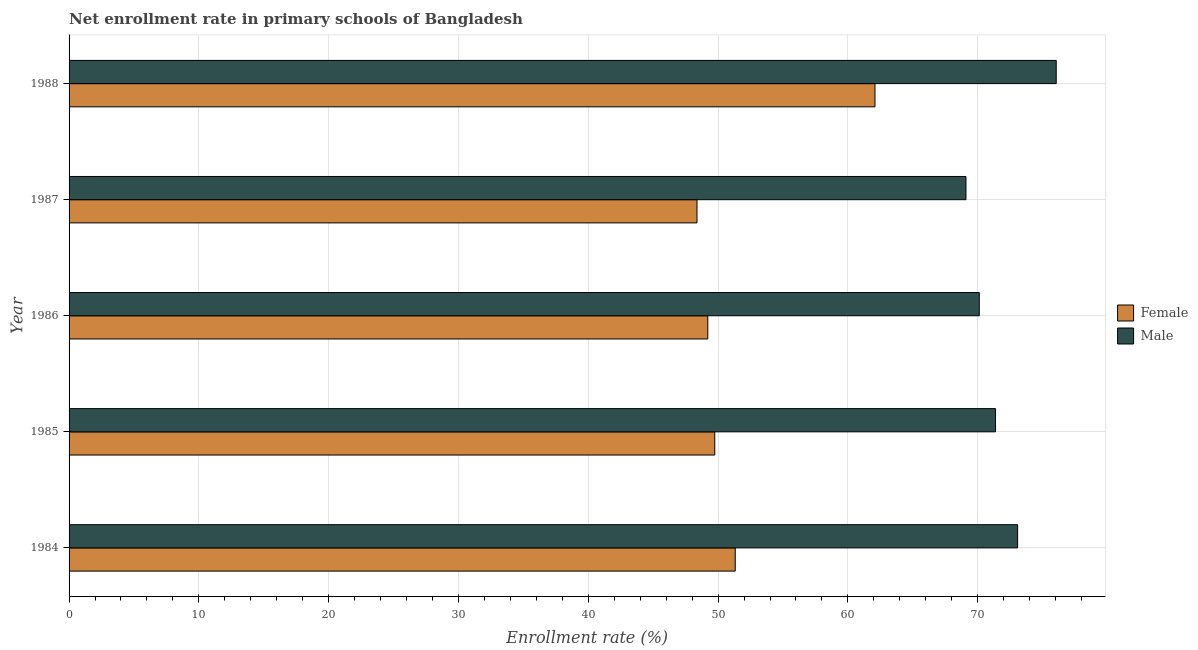How many groups of bars are there?
Ensure brevity in your answer.  5. Are the number of bars per tick equal to the number of legend labels?
Make the answer very short. Yes. Are the number of bars on each tick of the Y-axis equal?
Provide a succinct answer. Yes. How many bars are there on the 4th tick from the top?
Offer a terse response. 2. In how many cases, is the number of bars for a given year not equal to the number of legend labels?
Provide a succinct answer. 0. What is the enrollment rate of female students in 1985?
Keep it short and to the point. 49.74. Across all years, what is the maximum enrollment rate of male students?
Your answer should be very brief. 76.05. Across all years, what is the minimum enrollment rate of female students?
Your answer should be very brief. 48.38. In which year was the enrollment rate of male students maximum?
Offer a terse response. 1988. What is the total enrollment rate of male students in the graph?
Keep it short and to the point. 359.72. What is the difference between the enrollment rate of male students in 1987 and that in 1988?
Give a very brief answer. -6.95. What is the difference between the enrollment rate of male students in 1986 and the enrollment rate of female students in 1987?
Your answer should be compact. 21.75. What is the average enrollment rate of female students per year?
Ensure brevity in your answer.  52.15. In the year 1986, what is the difference between the enrollment rate of female students and enrollment rate of male students?
Your answer should be compact. -20.91. In how many years, is the enrollment rate of female students greater than 18 %?
Make the answer very short. 5. What is the ratio of the enrollment rate of male students in 1985 to that in 1987?
Provide a succinct answer. 1.03. Is the enrollment rate of male students in 1984 less than that in 1986?
Your answer should be very brief. No. What is the difference between the highest and the second highest enrollment rate of male students?
Offer a very short reply. 2.97. What is the difference between the highest and the lowest enrollment rate of female students?
Your answer should be very brief. 13.71. In how many years, is the enrollment rate of male students greater than the average enrollment rate of male students taken over all years?
Provide a short and direct response. 2. Is the sum of the enrollment rate of male students in 1985 and 1987 greater than the maximum enrollment rate of female students across all years?
Your response must be concise. Yes. Are all the bars in the graph horizontal?
Provide a short and direct response. Yes. What is the difference between two consecutive major ticks on the X-axis?
Your answer should be very brief. 10. Are the values on the major ticks of X-axis written in scientific E-notation?
Give a very brief answer. No. How many legend labels are there?
Provide a succinct answer. 2. How are the legend labels stacked?
Make the answer very short. Vertical. What is the title of the graph?
Your answer should be compact. Net enrollment rate in primary schools of Bangladesh. What is the label or title of the X-axis?
Keep it short and to the point. Enrollment rate (%). What is the label or title of the Y-axis?
Keep it short and to the point. Year. What is the Enrollment rate (%) of Female in 1984?
Give a very brief answer. 51.32. What is the Enrollment rate (%) in Male in 1984?
Provide a succinct answer. 73.08. What is the Enrollment rate (%) of Female in 1985?
Ensure brevity in your answer.  49.74. What is the Enrollment rate (%) of Male in 1985?
Provide a succinct answer. 71.38. What is the Enrollment rate (%) in Female in 1986?
Provide a short and direct response. 49.21. What is the Enrollment rate (%) of Male in 1986?
Give a very brief answer. 70.12. What is the Enrollment rate (%) of Female in 1987?
Offer a very short reply. 48.38. What is the Enrollment rate (%) in Male in 1987?
Provide a short and direct response. 69.1. What is the Enrollment rate (%) of Female in 1988?
Give a very brief answer. 62.09. What is the Enrollment rate (%) of Male in 1988?
Offer a terse response. 76.05. Across all years, what is the maximum Enrollment rate (%) of Female?
Provide a short and direct response. 62.09. Across all years, what is the maximum Enrollment rate (%) of Male?
Give a very brief answer. 76.05. Across all years, what is the minimum Enrollment rate (%) of Female?
Provide a short and direct response. 48.38. Across all years, what is the minimum Enrollment rate (%) of Male?
Make the answer very short. 69.1. What is the total Enrollment rate (%) in Female in the graph?
Ensure brevity in your answer.  260.74. What is the total Enrollment rate (%) of Male in the graph?
Offer a terse response. 359.72. What is the difference between the Enrollment rate (%) of Female in 1984 and that in 1985?
Ensure brevity in your answer.  1.58. What is the difference between the Enrollment rate (%) in Male in 1984 and that in 1985?
Provide a short and direct response. 1.7. What is the difference between the Enrollment rate (%) in Female in 1984 and that in 1986?
Keep it short and to the point. 2.11. What is the difference between the Enrollment rate (%) of Male in 1984 and that in 1986?
Provide a short and direct response. 2.95. What is the difference between the Enrollment rate (%) of Female in 1984 and that in 1987?
Provide a succinct answer. 2.95. What is the difference between the Enrollment rate (%) in Male in 1984 and that in 1987?
Ensure brevity in your answer.  3.98. What is the difference between the Enrollment rate (%) in Female in 1984 and that in 1988?
Provide a short and direct response. -10.77. What is the difference between the Enrollment rate (%) of Male in 1984 and that in 1988?
Offer a very short reply. -2.97. What is the difference between the Enrollment rate (%) of Female in 1985 and that in 1986?
Make the answer very short. 0.54. What is the difference between the Enrollment rate (%) of Male in 1985 and that in 1986?
Provide a succinct answer. 1.25. What is the difference between the Enrollment rate (%) in Female in 1985 and that in 1987?
Ensure brevity in your answer.  1.37. What is the difference between the Enrollment rate (%) in Male in 1985 and that in 1987?
Ensure brevity in your answer.  2.28. What is the difference between the Enrollment rate (%) of Female in 1985 and that in 1988?
Offer a terse response. -12.34. What is the difference between the Enrollment rate (%) in Male in 1985 and that in 1988?
Your response must be concise. -4.68. What is the difference between the Enrollment rate (%) in Female in 1986 and that in 1987?
Ensure brevity in your answer.  0.83. What is the difference between the Enrollment rate (%) of Male in 1986 and that in 1987?
Keep it short and to the point. 1.03. What is the difference between the Enrollment rate (%) in Female in 1986 and that in 1988?
Make the answer very short. -12.88. What is the difference between the Enrollment rate (%) of Male in 1986 and that in 1988?
Your response must be concise. -5.93. What is the difference between the Enrollment rate (%) in Female in 1987 and that in 1988?
Give a very brief answer. -13.71. What is the difference between the Enrollment rate (%) of Male in 1987 and that in 1988?
Keep it short and to the point. -6.95. What is the difference between the Enrollment rate (%) of Female in 1984 and the Enrollment rate (%) of Male in 1985?
Offer a terse response. -20.05. What is the difference between the Enrollment rate (%) in Female in 1984 and the Enrollment rate (%) in Male in 1986?
Your response must be concise. -18.8. What is the difference between the Enrollment rate (%) of Female in 1984 and the Enrollment rate (%) of Male in 1987?
Offer a very short reply. -17.78. What is the difference between the Enrollment rate (%) in Female in 1984 and the Enrollment rate (%) in Male in 1988?
Ensure brevity in your answer.  -24.73. What is the difference between the Enrollment rate (%) in Female in 1985 and the Enrollment rate (%) in Male in 1986?
Offer a terse response. -20.38. What is the difference between the Enrollment rate (%) of Female in 1985 and the Enrollment rate (%) of Male in 1987?
Give a very brief answer. -19.35. What is the difference between the Enrollment rate (%) of Female in 1985 and the Enrollment rate (%) of Male in 1988?
Offer a terse response. -26.31. What is the difference between the Enrollment rate (%) in Female in 1986 and the Enrollment rate (%) in Male in 1987?
Give a very brief answer. -19.89. What is the difference between the Enrollment rate (%) of Female in 1986 and the Enrollment rate (%) of Male in 1988?
Provide a short and direct response. -26.84. What is the difference between the Enrollment rate (%) in Female in 1987 and the Enrollment rate (%) in Male in 1988?
Provide a short and direct response. -27.68. What is the average Enrollment rate (%) in Female per year?
Your response must be concise. 52.15. What is the average Enrollment rate (%) in Male per year?
Your answer should be compact. 71.94. In the year 1984, what is the difference between the Enrollment rate (%) of Female and Enrollment rate (%) of Male?
Keep it short and to the point. -21.76. In the year 1985, what is the difference between the Enrollment rate (%) in Female and Enrollment rate (%) in Male?
Give a very brief answer. -21.63. In the year 1986, what is the difference between the Enrollment rate (%) of Female and Enrollment rate (%) of Male?
Provide a short and direct response. -20.91. In the year 1987, what is the difference between the Enrollment rate (%) in Female and Enrollment rate (%) in Male?
Offer a terse response. -20.72. In the year 1988, what is the difference between the Enrollment rate (%) in Female and Enrollment rate (%) in Male?
Ensure brevity in your answer.  -13.96. What is the ratio of the Enrollment rate (%) of Female in 1984 to that in 1985?
Provide a succinct answer. 1.03. What is the ratio of the Enrollment rate (%) of Male in 1984 to that in 1985?
Your answer should be compact. 1.02. What is the ratio of the Enrollment rate (%) in Female in 1984 to that in 1986?
Keep it short and to the point. 1.04. What is the ratio of the Enrollment rate (%) of Male in 1984 to that in 1986?
Offer a terse response. 1.04. What is the ratio of the Enrollment rate (%) of Female in 1984 to that in 1987?
Offer a terse response. 1.06. What is the ratio of the Enrollment rate (%) of Male in 1984 to that in 1987?
Offer a very short reply. 1.06. What is the ratio of the Enrollment rate (%) in Female in 1984 to that in 1988?
Provide a succinct answer. 0.83. What is the ratio of the Enrollment rate (%) in Male in 1984 to that in 1988?
Provide a short and direct response. 0.96. What is the ratio of the Enrollment rate (%) of Female in 1985 to that in 1986?
Keep it short and to the point. 1.01. What is the ratio of the Enrollment rate (%) of Male in 1985 to that in 1986?
Provide a succinct answer. 1.02. What is the ratio of the Enrollment rate (%) in Female in 1985 to that in 1987?
Your answer should be very brief. 1.03. What is the ratio of the Enrollment rate (%) in Male in 1985 to that in 1987?
Your response must be concise. 1.03. What is the ratio of the Enrollment rate (%) of Female in 1985 to that in 1988?
Your response must be concise. 0.8. What is the ratio of the Enrollment rate (%) of Male in 1985 to that in 1988?
Provide a succinct answer. 0.94. What is the ratio of the Enrollment rate (%) of Female in 1986 to that in 1987?
Your response must be concise. 1.02. What is the ratio of the Enrollment rate (%) in Male in 1986 to that in 1987?
Offer a very short reply. 1.01. What is the ratio of the Enrollment rate (%) of Female in 1986 to that in 1988?
Provide a succinct answer. 0.79. What is the ratio of the Enrollment rate (%) of Male in 1986 to that in 1988?
Make the answer very short. 0.92. What is the ratio of the Enrollment rate (%) in Female in 1987 to that in 1988?
Make the answer very short. 0.78. What is the ratio of the Enrollment rate (%) in Male in 1987 to that in 1988?
Make the answer very short. 0.91. What is the difference between the highest and the second highest Enrollment rate (%) of Female?
Your answer should be very brief. 10.77. What is the difference between the highest and the second highest Enrollment rate (%) in Male?
Your answer should be very brief. 2.97. What is the difference between the highest and the lowest Enrollment rate (%) in Female?
Offer a terse response. 13.71. What is the difference between the highest and the lowest Enrollment rate (%) of Male?
Your answer should be very brief. 6.95. 